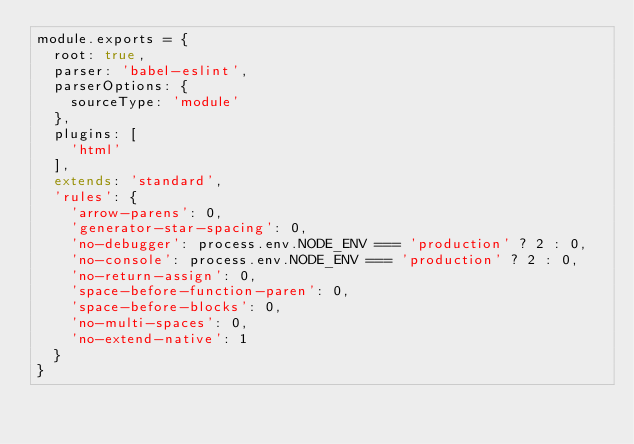Convert code to text. <code><loc_0><loc_0><loc_500><loc_500><_JavaScript_>module.exports = {
  root: true,
  parser: 'babel-eslint',
  parserOptions: {
    sourceType: 'module'
  },
  plugins: [
    'html'
  ],
  extends: 'standard',
  'rules': {
    'arrow-parens': 0,
    'generator-star-spacing': 0,
    'no-debugger': process.env.NODE_ENV === 'production' ? 2 : 0,
    'no-console': process.env.NODE_ENV === 'production' ? 2 : 0,
    'no-return-assign': 0,
    'space-before-function-paren': 0,
    'space-before-blocks': 0,
    'no-multi-spaces': 0,
    'no-extend-native': 1
  }
}
</code> 